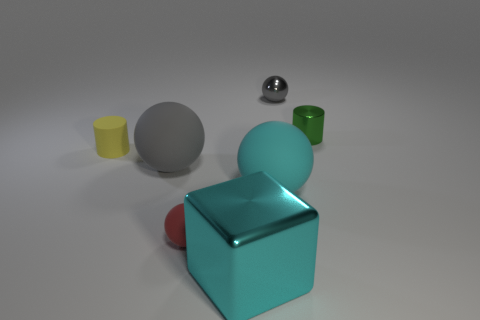There is a large sphere that is the same color as the big block; what is it made of?
Make the answer very short. Rubber. There is a big matte ball that is in front of the gray rubber sphere; what is its color?
Provide a succinct answer. Cyan. There is a gray sphere that is to the right of the big rubber ball right of the large cyan metal thing; how big is it?
Give a very brief answer. Small. There is a big rubber thing that is right of the big cyan block; does it have the same shape as the large metal thing?
Provide a short and direct response. No. There is a big gray thing that is the same shape as the small red object; what is it made of?
Provide a short and direct response. Rubber. What number of things are either metal objects in front of the big cyan ball or cyan things that are right of the large shiny cube?
Provide a short and direct response. 2. There is a matte cylinder; does it have the same color as the tiny metallic thing on the left side of the green object?
Offer a terse response. No. The other tiny object that is made of the same material as the red thing is what shape?
Provide a short and direct response. Cylinder. What number of small yellow matte blocks are there?
Provide a succinct answer. 0. What number of objects are metallic things to the left of the green thing or small green metallic cylinders?
Your response must be concise. 3. 